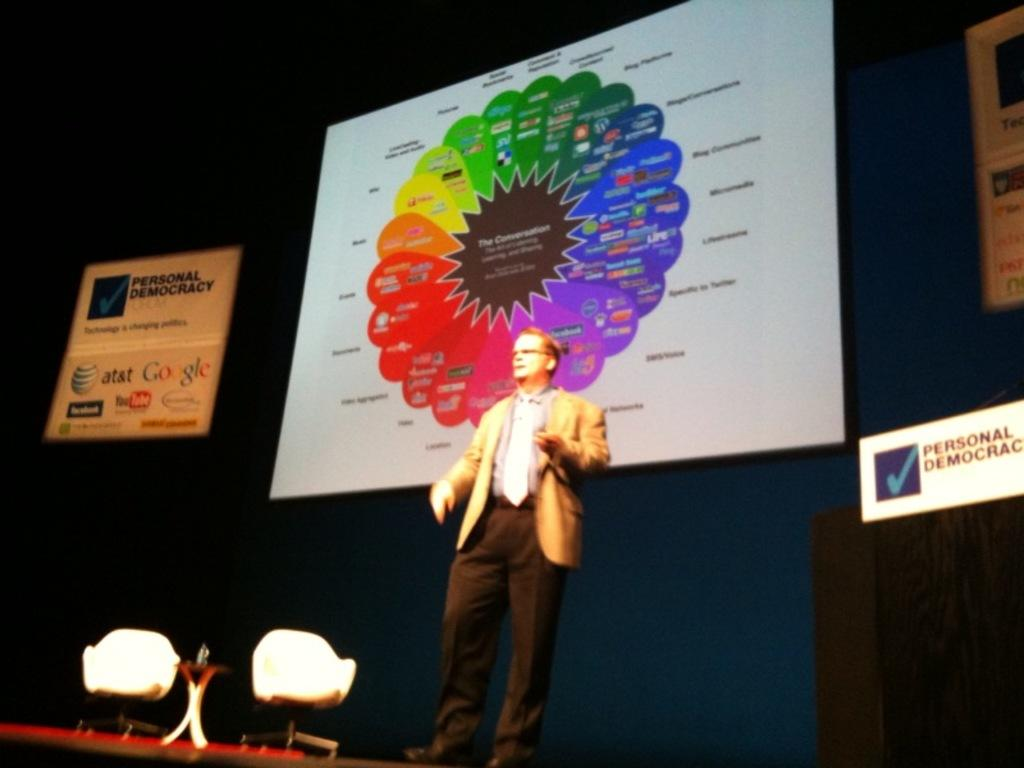What is the person in the image wearing? The person is wearing a suit. How many chairs are in the image? There are two chairs in the image. What is the primary piece of furniture in the image? There is a table in the image. What can be seen on the screen in the background of the image? There is text on the screen in the background of the image. How many chickens are sitting on the person's finger in the image? There are no chickens or fingers visible in the image. 